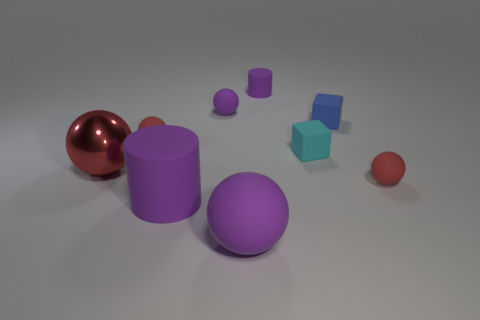Subtract all cyan cylinders. How many red spheres are left? 3 Subtract all red shiny spheres. How many spheres are left? 4 Subtract all blue spheres. Subtract all gray cylinders. How many spheres are left? 5 Subtract all cylinders. How many objects are left? 7 Add 3 tiny matte objects. How many tiny matte objects are left? 9 Add 1 small objects. How many small objects exist? 7 Subtract 0 brown cubes. How many objects are left? 9 Subtract all tiny purple cylinders. Subtract all big purple spheres. How many objects are left? 7 